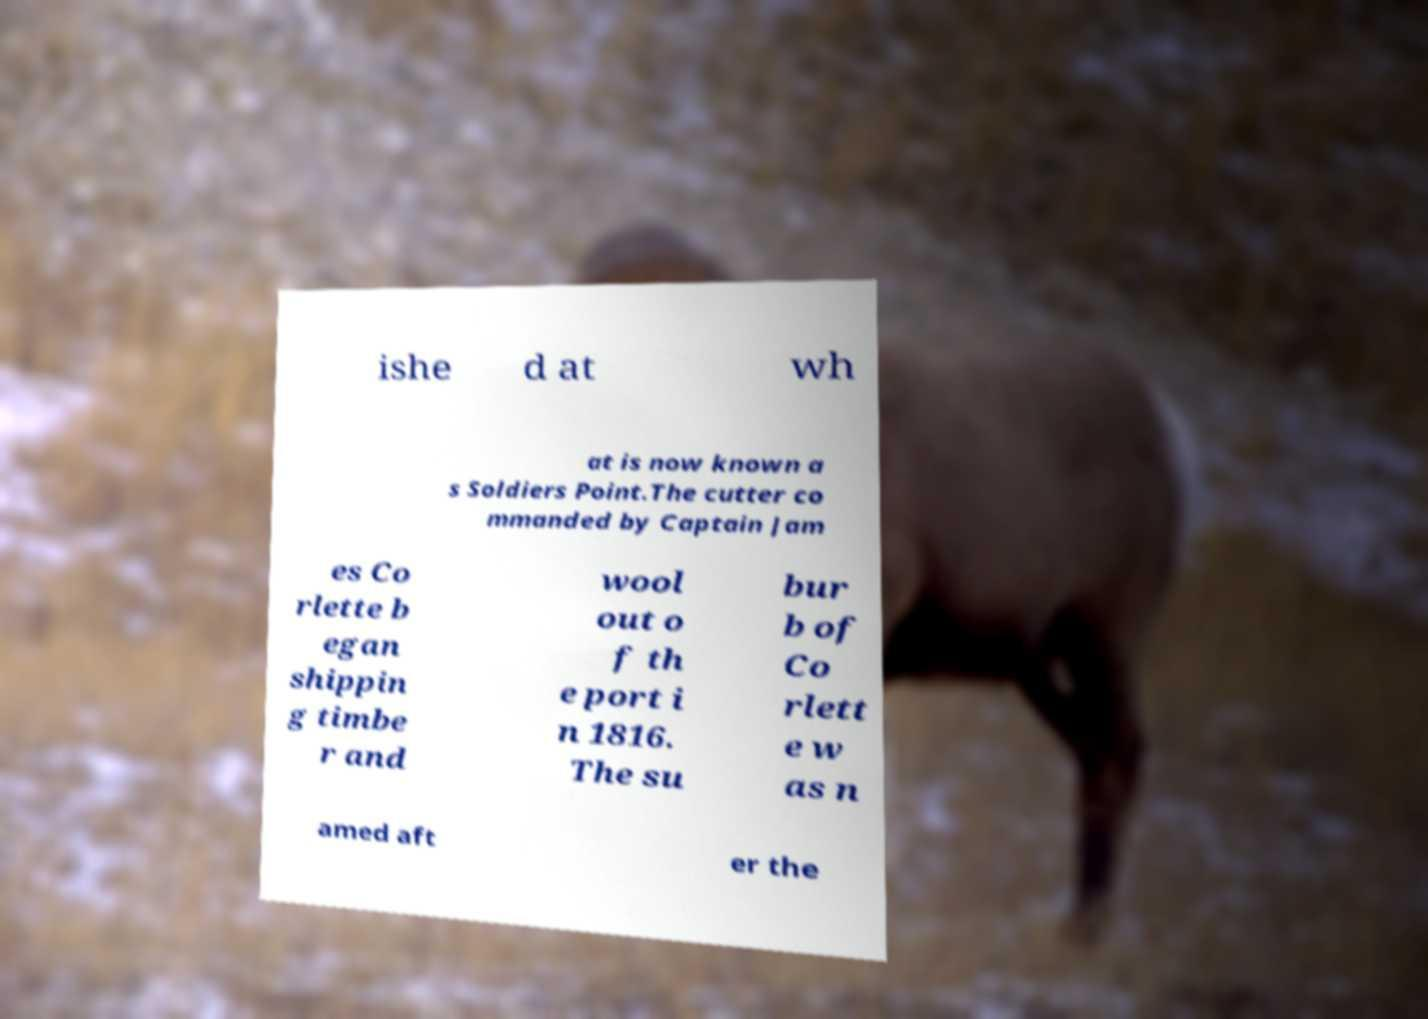Please identify and transcribe the text found in this image. ishe d at wh at is now known a s Soldiers Point.The cutter co mmanded by Captain Jam es Co rlette b egan shippin g timbe r and wool out o f th e port i n 1816. The su bur b of Co rlett e w as n amed aft er the 